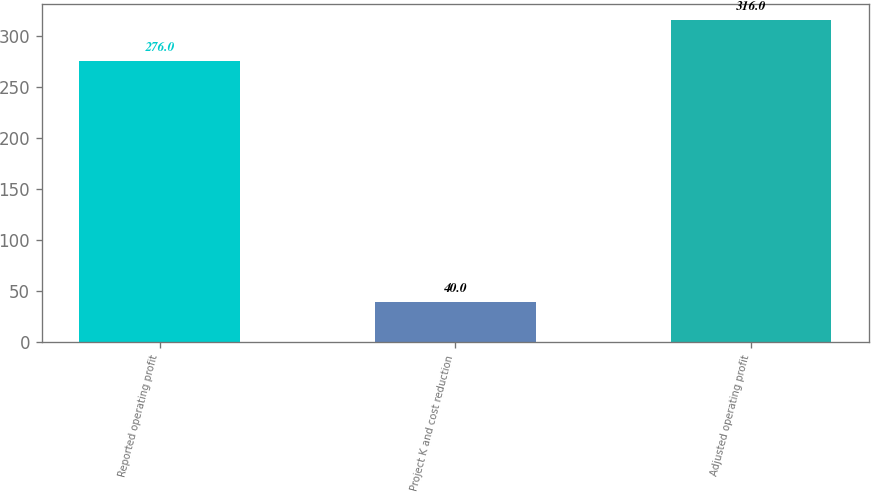Convert chart to OTSL. <chart><loc_0><loc_0><loc_500><loc_500><bar_chart><fcel>Reported operating profit<fcel>Project K and cost reduction<fcel>Adjusted operating profit<nl><fcel>276<fcel>40<fcel>316<nl></chart> 